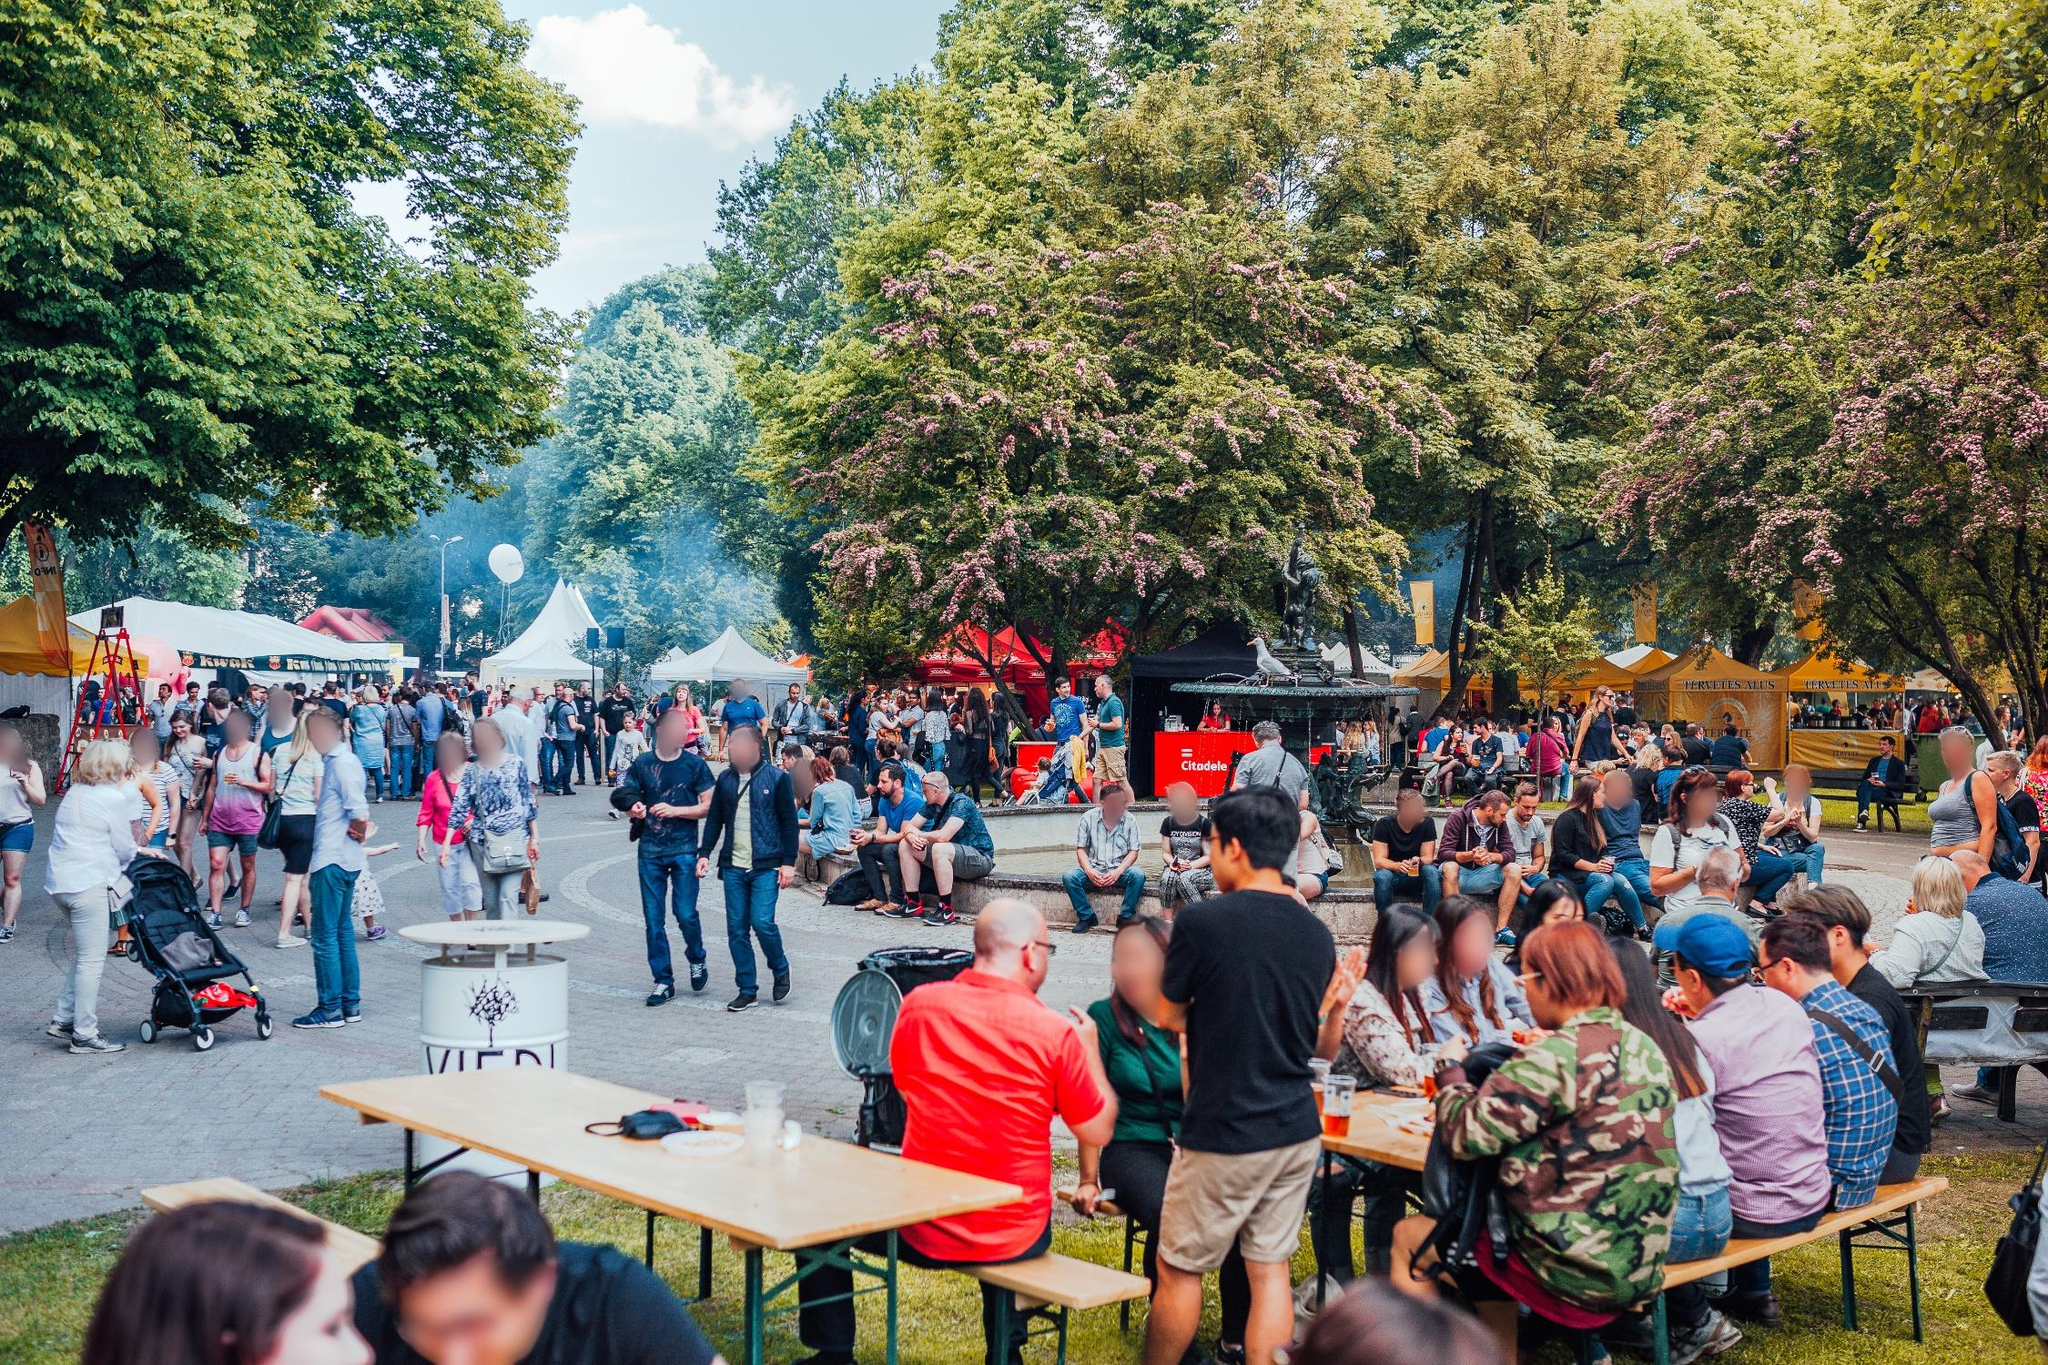Describe the mood and interactions among the people in the image. The mood in the image is lively and cheerful, with people engaged in light-hearted conversations and meals together. The interactions seem casual and friendly, with groups of people gathered around tables or walking together. There's a sense of community and relaxation as people take in the festival's offerings on a sunny day. 